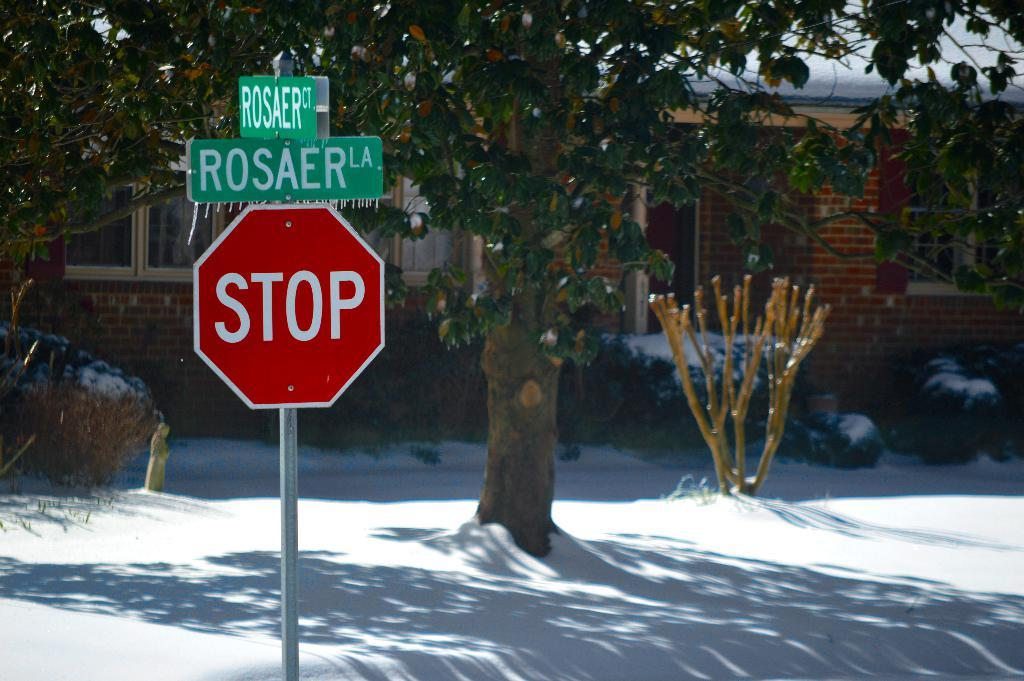<image>
Create a compact narrative representing the image presented. a stop sign that is outside with white snow on the ground 